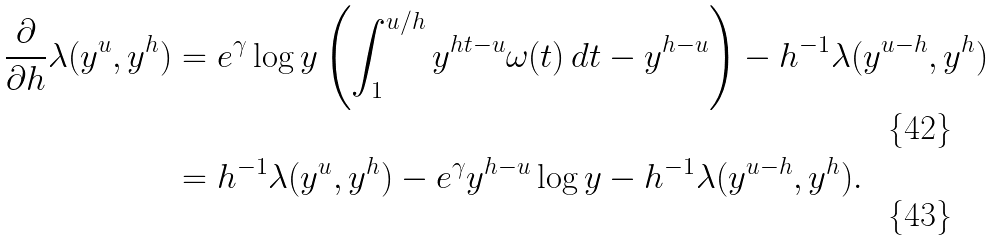<formula> <loc_0><loc_0><loc_500><loc_500>\frac { \partial } { \partial h } \lambda ( y ^ { u } , y ^ { h } ) & = e ^ { \gamma } \log y \left ( \int _ { 1 } ^ { u / h } y ^ { h t - u } \omega ( t ) \, d t - y ^ { h - u } \right ) - h ^ { - 1 } \lambda ( y ^ { u - h } , y ^ { h } ) \\ & = h ^ { - 1 } \lambda ( y ^ { u } , y ^ { h } ) - e ^ { \gamma } y ^ { h - u } \log y - h ^ { - 1 } \lambda ( y ^ { u - h } , y ^ { h } ) .</formula> 